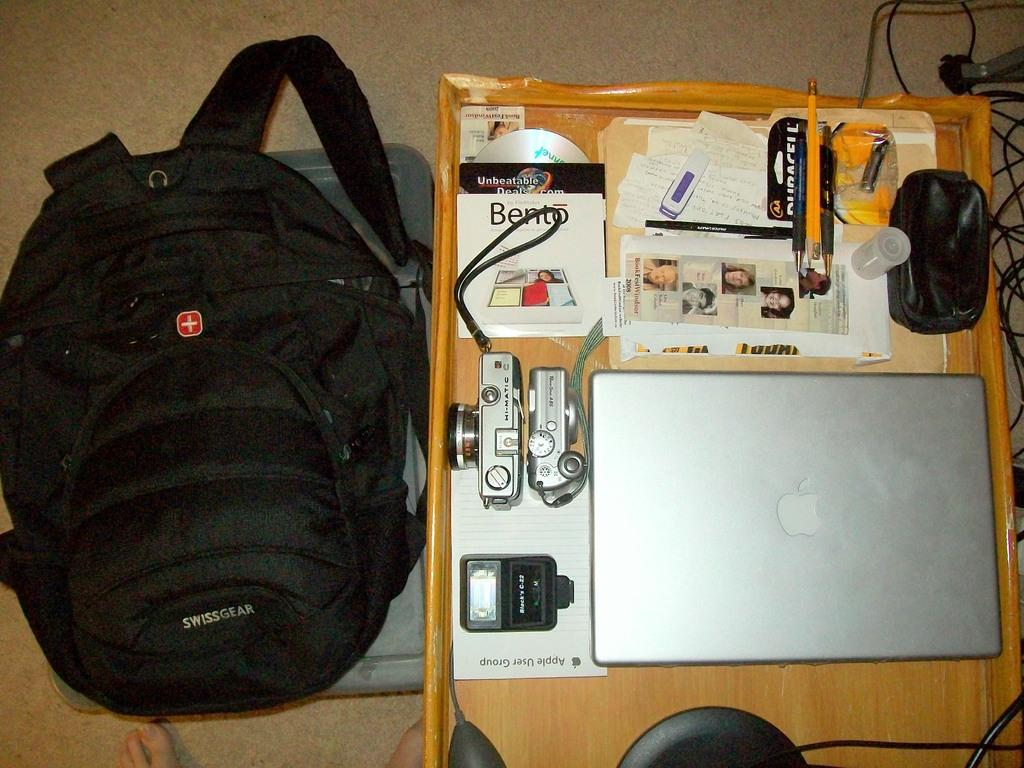<image>
Give a short and clear explanation of the subsequent image. A box for Bento by FileMaker sits in a drawer with other electronic gadgets. 